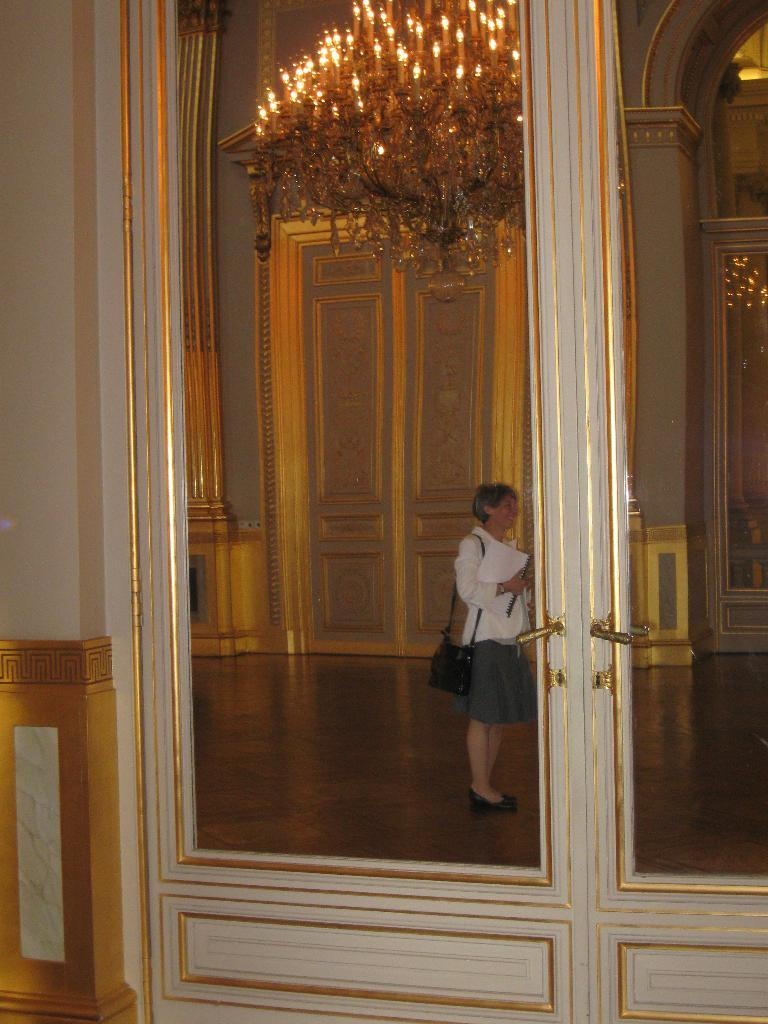What type of architectural feature can be seen in the image? There are doors in the image. What is hanging from the ceiling in the image? There is a chandelier in the image. What is the person in the image doing? The person is standing and holding a paper. What is the background of the image made of? There is a wall in the image. What type of sleet can be seen falling outside the doors in the image? There is no sleet visible in the image, as it is focused on the interior of the room with doors, a chandelier, a person holding a paper, and a wall. 